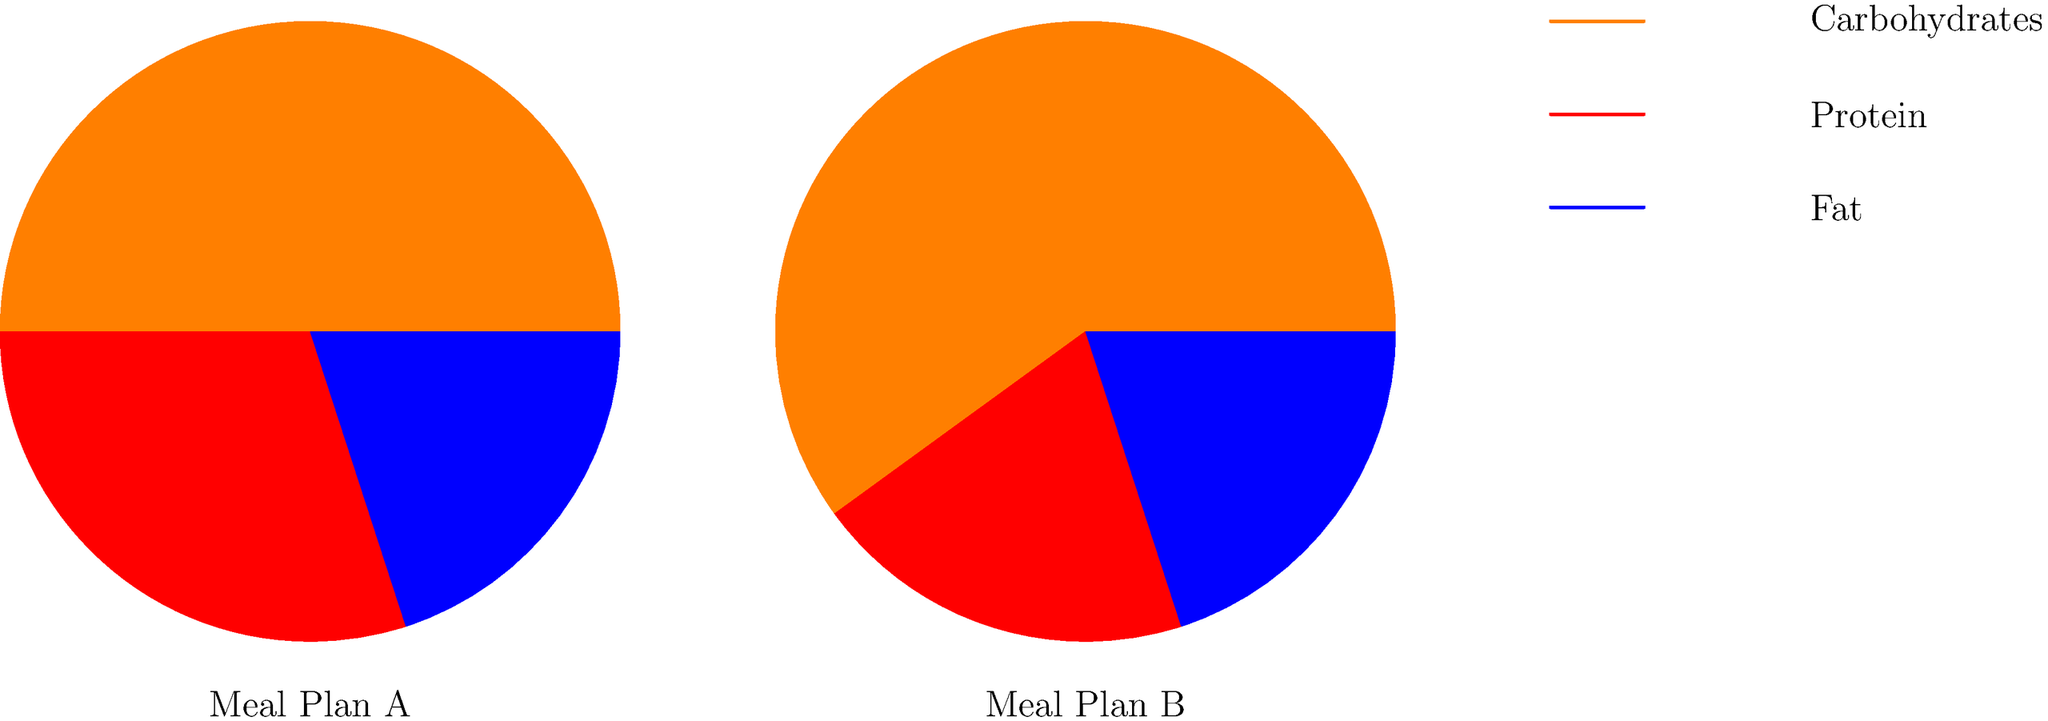Examine the pie charts representing two different meal plans for cricket players. Which meal plan provides a higher percentage of carbohydrates, and how does this align with the energy demands of cricket players during intense training or match days? To answer this question, let's analyze the pie charts step-by-step:

1. Meal Plan A:
   - Carbohydrates: 50%
   - Protein: 30%
   - Fat: 20%

2. Meal Plan B:
   - Carbohydrates: 60%
   - Protein: 20%
   - Fat: 20%

3. Comparing carbohydrate percentages:
   - Meal Plan B has a higher percentage of carbohydrates (60%) compared to Meal Plan A (50%).

4. Alignment with cricket players' energy demands:
   - Cricket involves periods of high-intensity activity interspersed with periods of lower intensity.
   - Carbohydrates are the primary and most efficient source of energy for high-intensity activities.
   - During intense training or match days, cricket players require a higher intake of carbohydrates to maintain energy levels and performance.

5. Benefits of higher carbohydrate intake for cricket players:
   - Provides readily available energy for explosive movements (e.g., sprinting between wickets, bowling, fielding).
   - Helps maintain glycogen stores in muscles and liver, which is crucial for endurance during long matches.
   - Supports recovery between training sessions or match days.

6. Conclusion:
   Meal Plan B, with its higher carbohydrate content (60%), better aligns with the energy demands of cricket players during intense training or match days. This higher carbohydrate intake can help players maintain their performance levels throughout the game and support their recovery.
Answer: Meal Plan B (60% carbohydrates) better aligns with cricket players' energy demands during intense activity. 